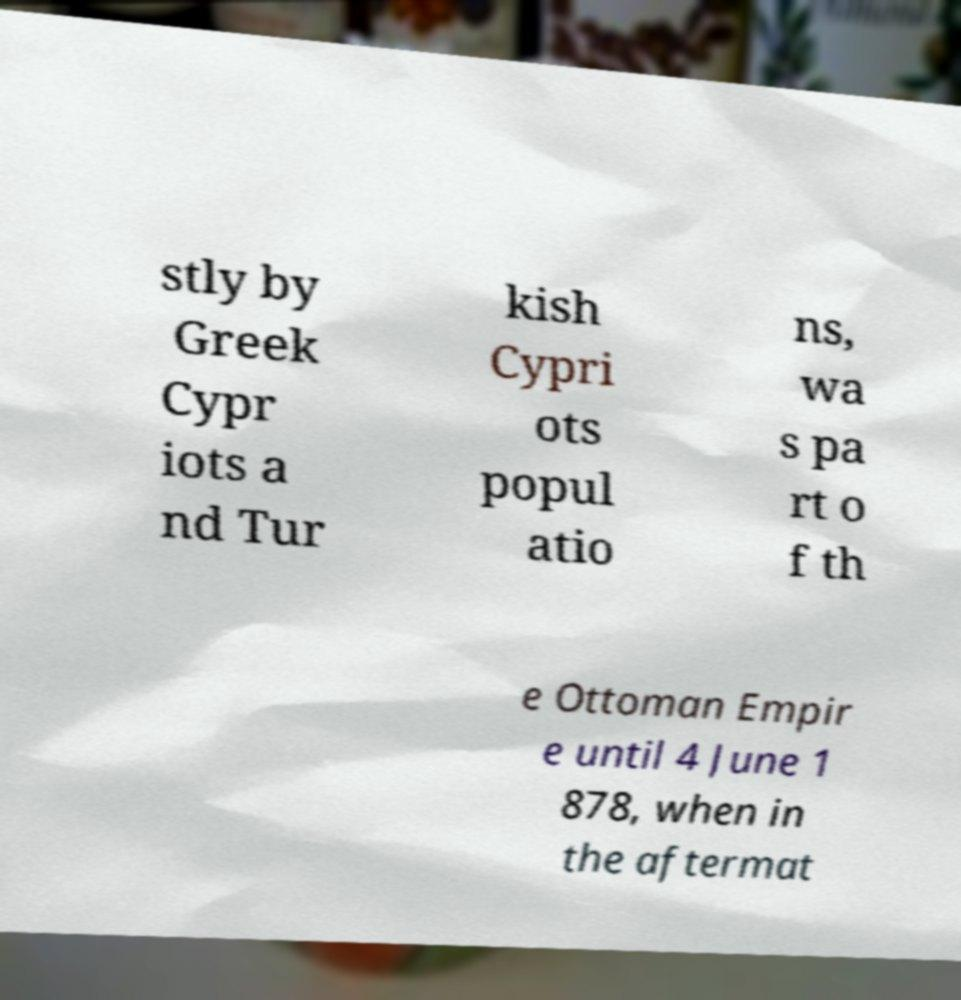For documentation purposes, I need the text within this image transcribed. Could you provide that? stly by Greek Cypr iots a nd Tur kish Cypri ots popul atio ns, wa s pa rt o f th e Ottoman Empir e until 4 June 1 878, when in the aftermat 